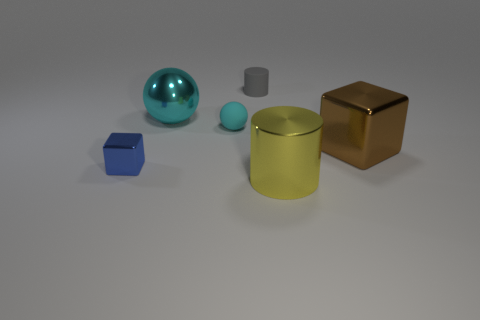What color is the metal thing that is to the left of the large cyan object?
Provide a succinct answer. Blue. What size is the blue block?
Offer a very short reply. Small. There is a yellow cylinder; is it the same size as the metallic cube that is right of the small gray cylinder?
Your answer should be very brief. Yes. What is the color of the metal block that is left of the large object on the left side of the thing that is in front of the small metallic cube?
Give a very brief answer. Blue. Does the cyan sphere in front of the big cyan metallic ball have the same material as the large cylinder?
Give a very brief answer. No. How many other objects are there of the same material as the gray cylinder?
Your response must be concise. 1. There is a ball that is the same size as the brown thing; what material is it?
Ensure brevity in your answer.  Metal. Do the large metal object to the left of the tiny cyan matte sphere and the large thing that is to the right of the yellow metallic cylinder have the same shape?
Make the answer very short. No. There is a cyan metal object that is the same size as the brown thing; what is its shape?
Give a very brief answer. Sphere. Do the large object left of the gray cylinder and the big thing that is right of the big yellow cylinder have the same material?
Ensure brevity in your answer.  Yes. 